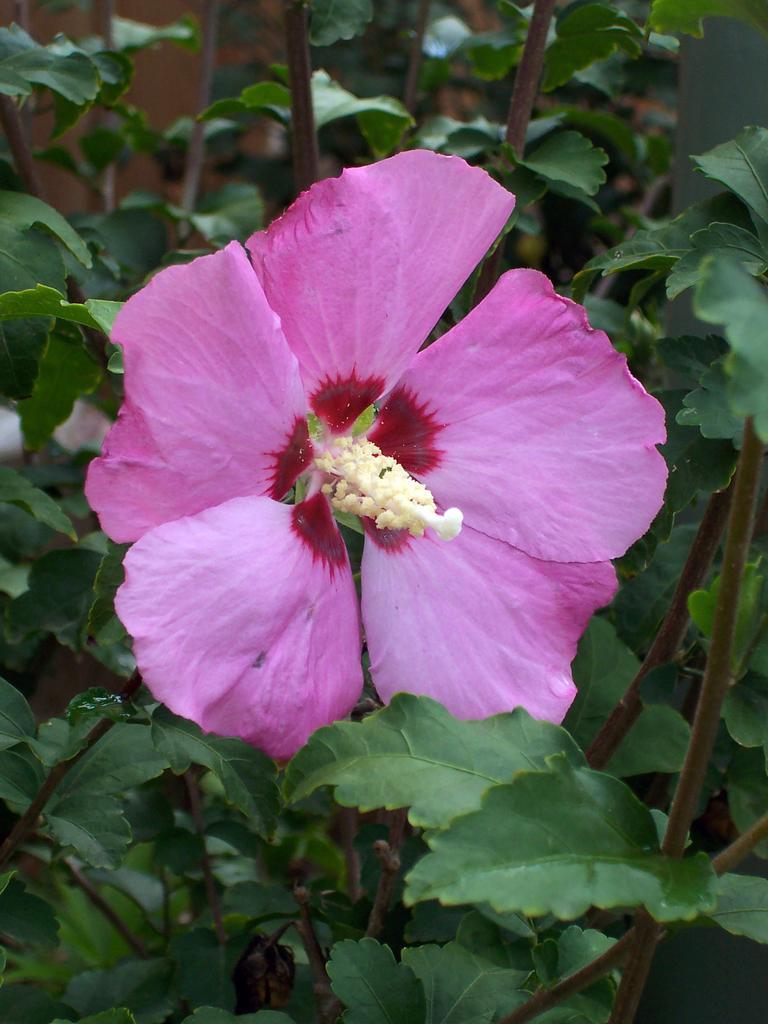Could you give a brief overview of what you see in this image? In this picture I can see a flower in the middle and there are plants. 